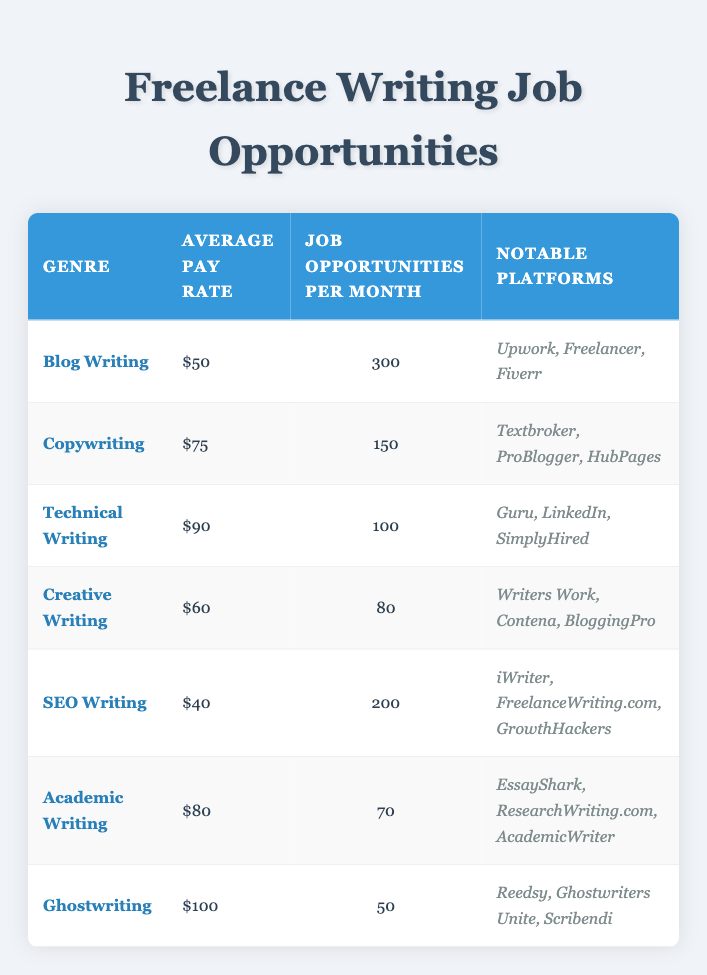What is the average pay rate for Ghostwriting? The table shows that the average pay rate for Ghostwriting is listed directly under the "Average Pay Rate" column next to the "Ghostwriting" genre row, which is 100.
Answer: 100 How many job opportunities are available for Blog Writing per month? The table indicates that Job Opportunities per Month for Blog Writing can be found in the corresponding row under the "Job Opportunities per Month" column, where it states 300.
Answer: 300 Which genre has the highest average pay rate? To determine the highest average pay rate, we compare the average pay rates listed in the "Average Pay Rate" column: Blog Writing (50), Copywriting (75), Technical Writing (90), Creative Writing (60), SEO Writing (40), Academic Writing (80), and Ghostwriting (100). Ghostwriting has the highest pay rate at 100.
Answer: Ghostwriting True or False: There are 200 job opportunities per month for SEO Writing. The table specifies that the number of job opportunities for SEO Writing is 200, so this statement is accurate.
Answer: True What is the total average pay rate for all writing genres combined? To find the total average pay rate, sum the average pay rates for all genres: 50 + 75 + 90 + 60 + 40 + 80 + 100 = 495. There are a total of seven genres, so the average pay rate is 495 / 7 = 70.71.
Answer: 70.71 Which platform is notable for both Blog Writing and SEO Writing? We examine the notable platforms for each genre: Blog Writing (Upwork, Freelancer, Fiverr) and SEO Writing (iWriter, FreelanceWriting.com, GrowthHackers). There are no overlapping platforms listed, indicating that none are common between Blog Writing and SEO Writing.
Answer: None How many job opportunities are there for Technical Writing compared to Creative Writing? The table shows 100 job opportunities for Technical Writing and 80 for Creative Writing. Therefore, to compare, we note that Technical Writing has 20 more opportunities than Creative Writing (100 - 80 = 20).
Answer: 20 more for Technical Writing Is the pay rate for Academic Writing higher than that for Blog Writing? Comparing the average pay rates, Academic Writing has an average pay rate of 80, while Blog Writing has a pay rate of 50. Since 80 is greater than 50, the statement is true.
Answer: Yes What are the notable platforms for Copywriting? The notable platforms for Copywriting are listed directly in the table under the "Notable Platforms" column for the Copywriting row, which includes Textbroker, ProBlogger, and HubPages.
Answer: Textbroker, ProBlogger, HubPages 